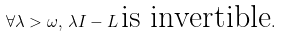<formula> <loc_0><loc_0><loc_500><loc_500>\forall \lambda > \omega , \, \lambda I - L \, \text {is invertible} .</formula> 